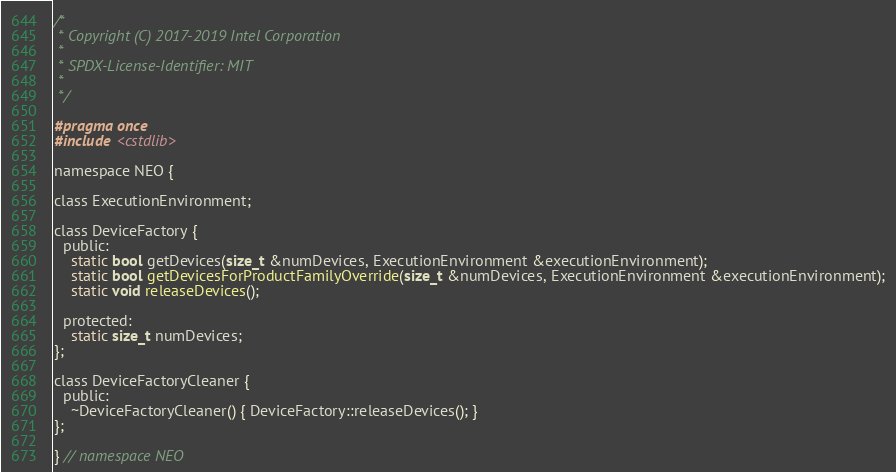Convert code to text. <code><loc_0><loc_0><loc_500><loc_500><_C_>/*
 * Copyright (C) 2017-2019 Intel Corporation
 *
 * SPDX-License-Identifier: MIT
 *
 */

#pragma once
#include <cstdlib>

namespace NEO {

class ExecutionEnvironment;

class DeviceFactory {
  public:
    static bool getDevices(size_t &numDevices, ExecutionEnvironment &executionEnvironment);
    static bool getDevicesForProductFamilyOverride(size_t &numDevices, ExecutionEnvironment &executionEnvironment);
    static void releaseDevices();

  protected:
    static size_t numDevices;
};

class DeviceFactoryCleaner {
  public:
    ~DeviceFactoryCleaner() { DeviceFactory::releaseDevices(); }
};

} // namespace NEO
</code> 